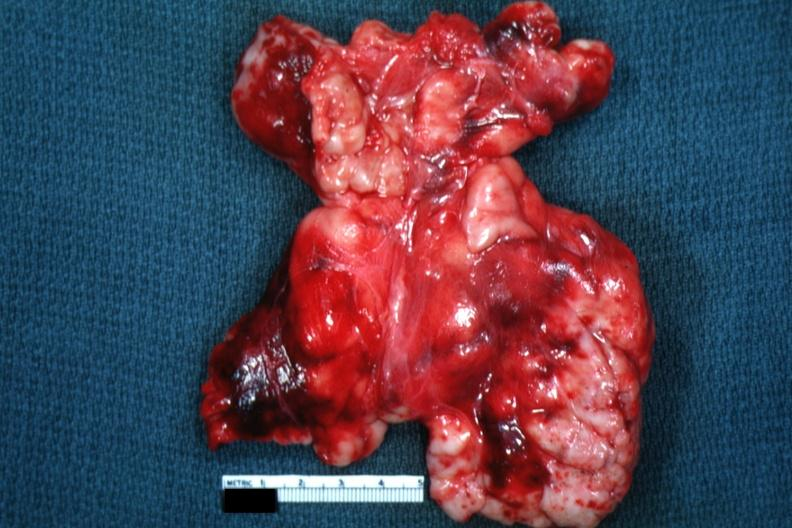s thymus present?
Answer the question using a single word or phrase. Yes 